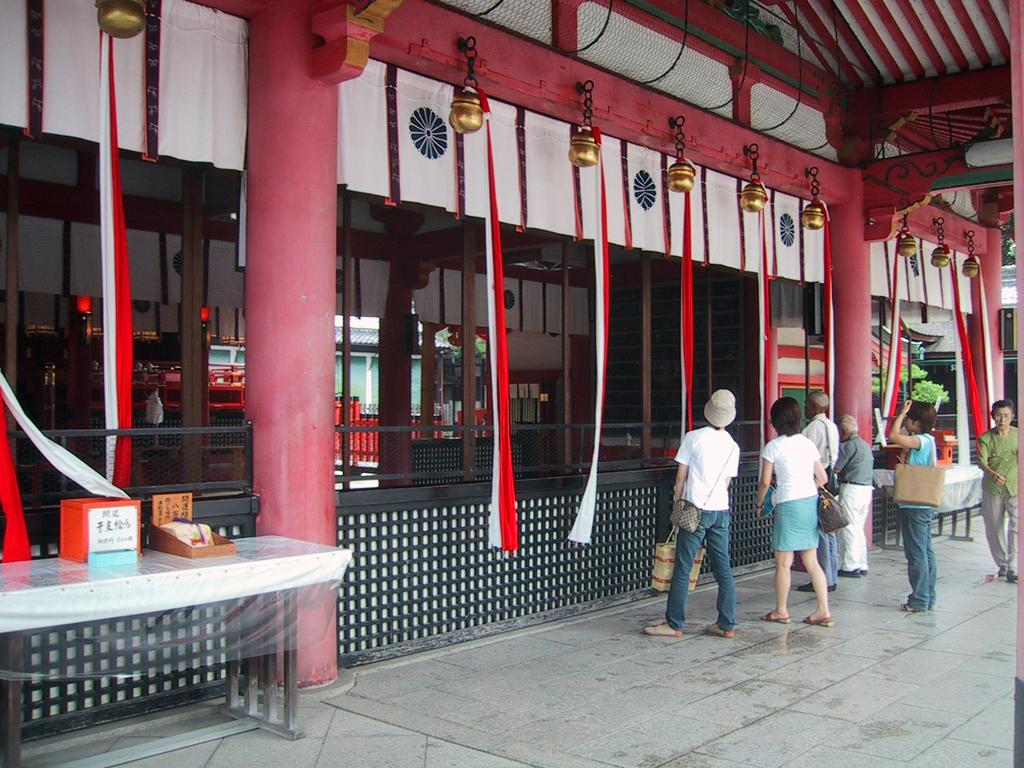What are the people in the image doing? The people in the image are standing. Is there any movement in the image? Yes, there is a woman walking in the image. What can be seen hanging in the image? Clothes are hanging in the image. What type of structure is visible in the image? There is a building in the image. What piece of furniture is present in the image? There is a table in the image. What is the position of the arm of the person sitting on the table in the image? There is no person sitting on the table in the image. What action is the arm taking in the image? There is no arm present in the image to take any action. 